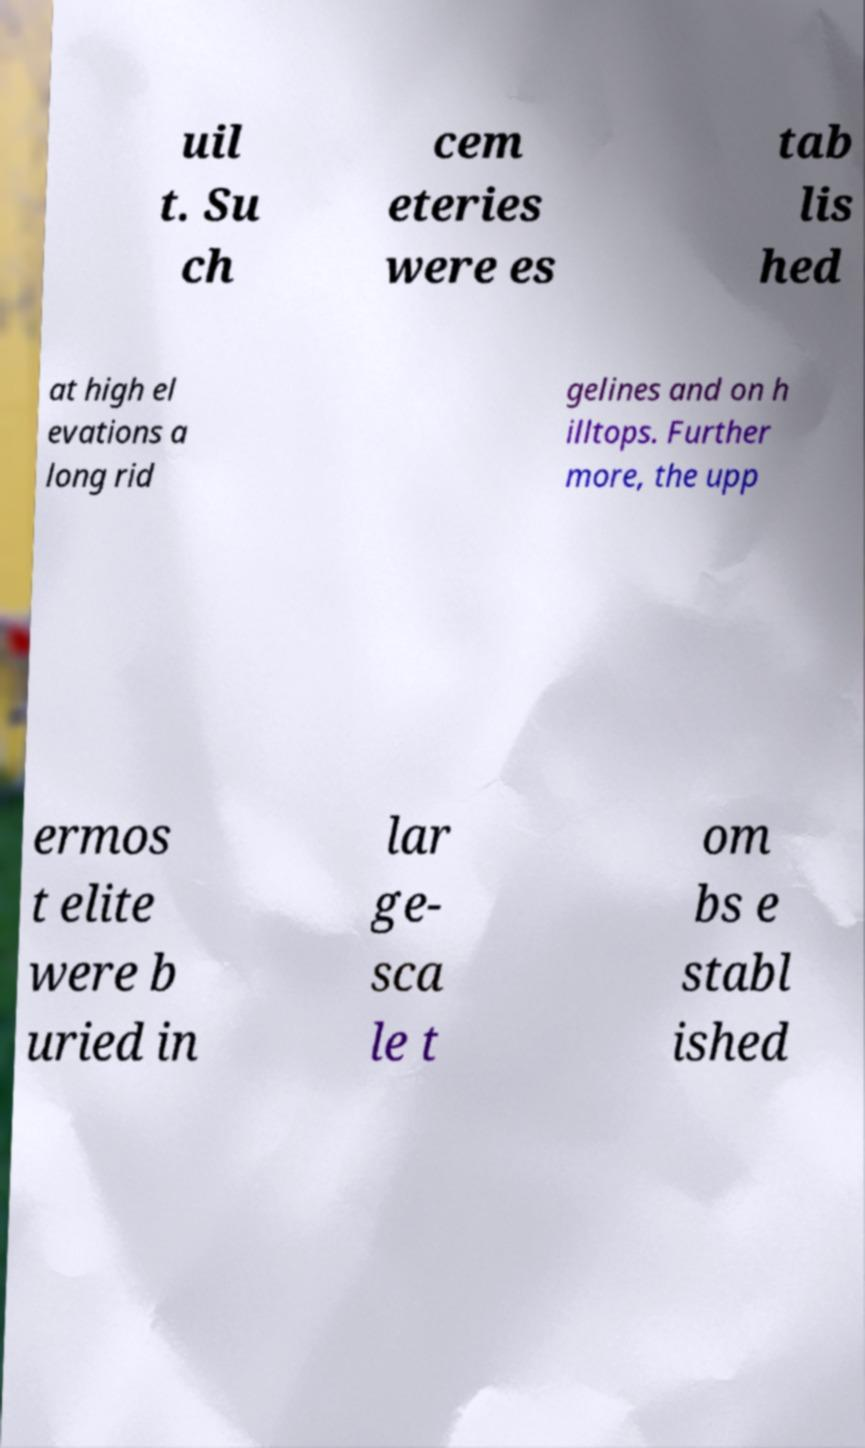Could you assist in decoding the text presented in this image and type it out clearly? uil t. Su ch cem eteries were es tab lis hed at high el evations a long rid gelines and on h illtops. Further more, the upp ermos t elite were b uried in lar ge- sca le t om bs e stabl ished 